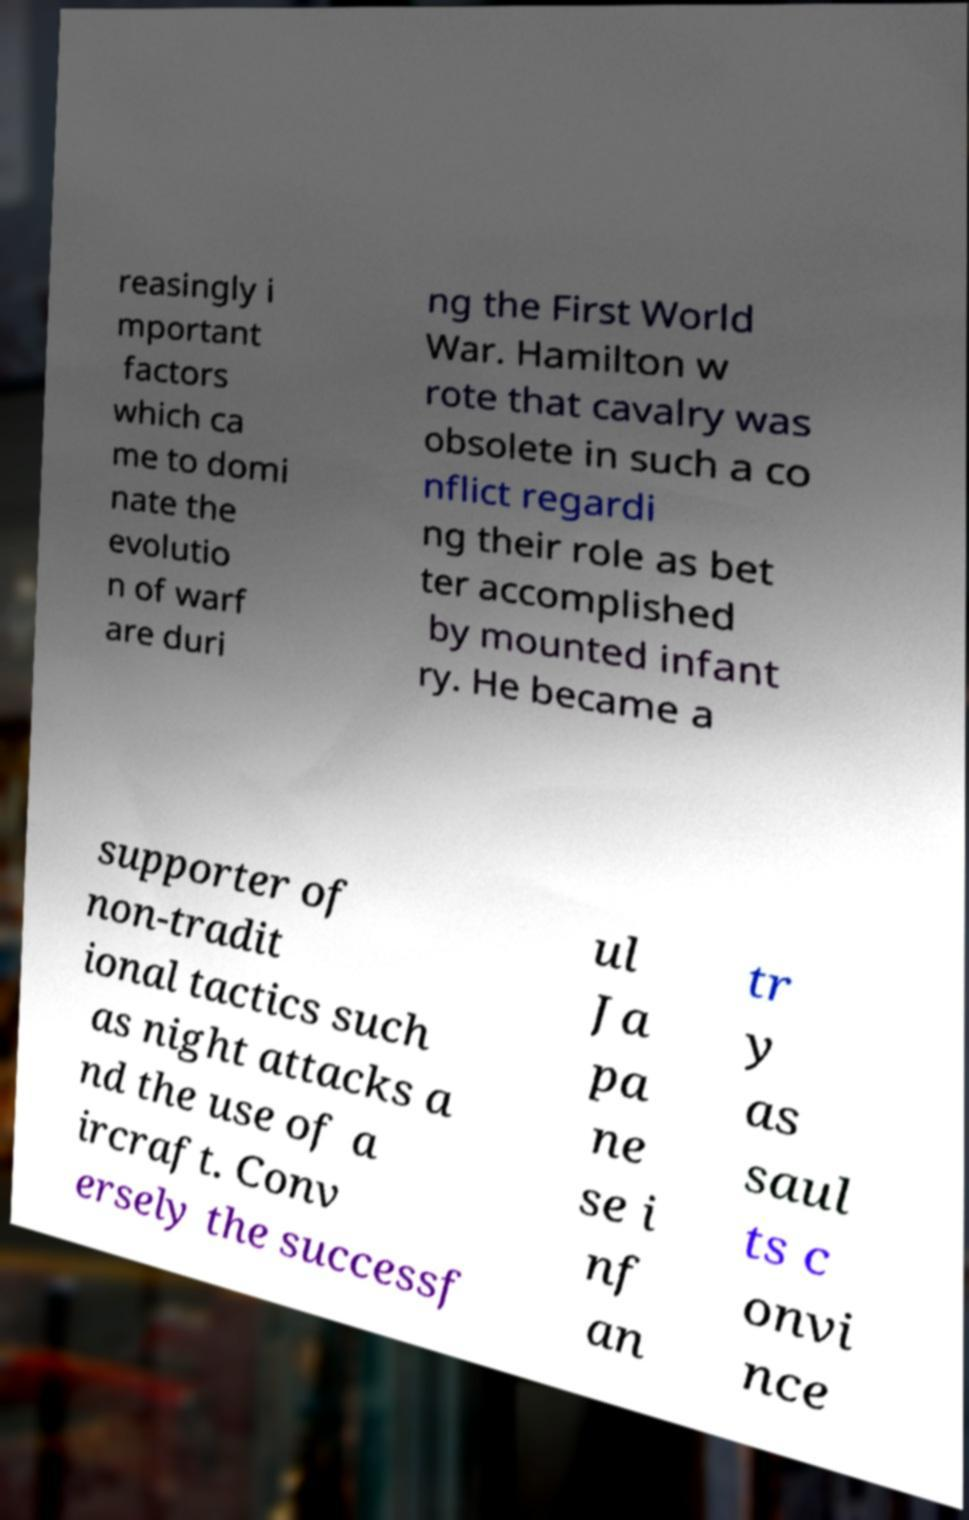There's text embedded in this image that I need extracted. Can you transcribe it verbatim? reasingly i mportant factors which ca me to domi nate the evolutio n of warf are duri ng the First World War. Hamilton w rote that cavalry was obsolete in such a co nflict regardi ng their role as bet ter accomplished by mounted infant ry. He became a supporter of non-tradit ional tactics such as night attacks a nd the use of a ircraft. Conv ersely the successf ul Ja pa ne se i nf an tr y as saul ts c onvi nce 